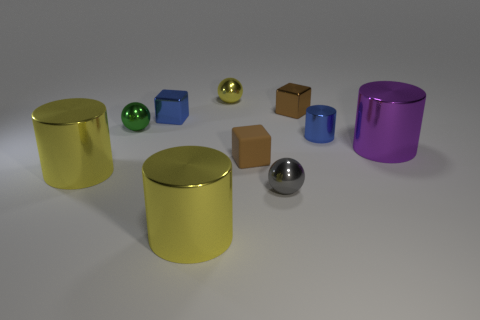What number of other things are the same size as the blue metallic cylinder?
Ensure brevity in your answer.  6. There is a matte object; does it have the same size as the metal cube that is to the left of the yellow ball?
Your answer should be compact. Yes. What color is the big metallic cylinder that is both to the right of the green metallic sphere and on the left side of the blue cylinder?
Provide a succinct answer. Yellow. Is there a object in front of the large yellow cylinder that is on the left side of the blue cube?
Offer a terse response. Yes. Are there the same number of blue metal cubes in front of the tiny rubber block and large purple metal cylinders?
Your answer should be very brief. No. There is a green thing that is behind the small blue thing that is right of the brown shiny cube; what number of cylinders are right of it?
Offer a terse response. 3. Are there any yellow shiny balls that have the same size as the rubber block?
Your answer should be compact. Yes. Are there fewer small brown things behind the purple metallic object than big yellow metallic objects?
Your answer should be very brief. Yes. What is the brown block in front of the big object that is behind the thing that is on the left side of the tiny green thing made of?
Your response must be concise. Rubber. Is the number of small brown cubes that are to the left of the tiny gray metal ball greater than the number of small blue shiny objects right of the blue cylinder?
Your response must be concise. Yes. 